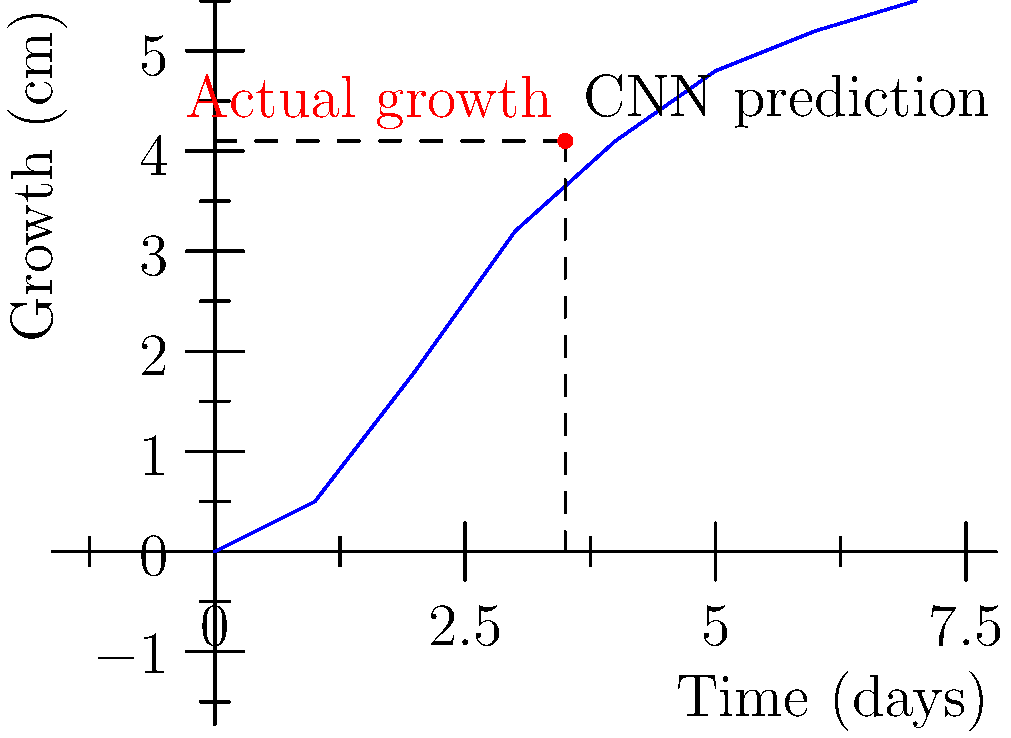In a plant growth prediction experiment using convolutional neural networks (CNNs) and time-lapse images, the graph shows the CNN's predicted growth curve for a seedling over 7 days. If the actual growth at day 3.5 is 4.1 cm, what is the absolute error of the CNN's prediction at this time point? Express your answer in centimeters, rounded to one decimal place. To solve this problem, we need to follow these steps:

1. Identify the CNN's predicted growth at day 3.5:
   - From the graph, we can estimate that at day 3.5, the CNN predicts a growth of approximately 3.7 cm.

2. Recall the actual growth at day 3.5:
   - The question states that the actual growth at day 3.5 is 4.1 cm.

3. Calculate the absolute error:
   - The absolute error is the absolute value of the difference between the predicted and actual values.
   - Absolute error = $|predicted value - actual value|$
   - Absolute error = $|3.7 cm - 4.1 cm|$
   - Absolute error = $|0.4 cm|$
   - Absolute error = 0.4 cm

4. Round to one decimal place:
   - 0.4 cm is already expressed to one decimal place, so no further rounding is necessary.

Therefore, the absolute error of the CNN's prediction at day 3.5 is 0.4 cm.
Answer: 0.4 cm 